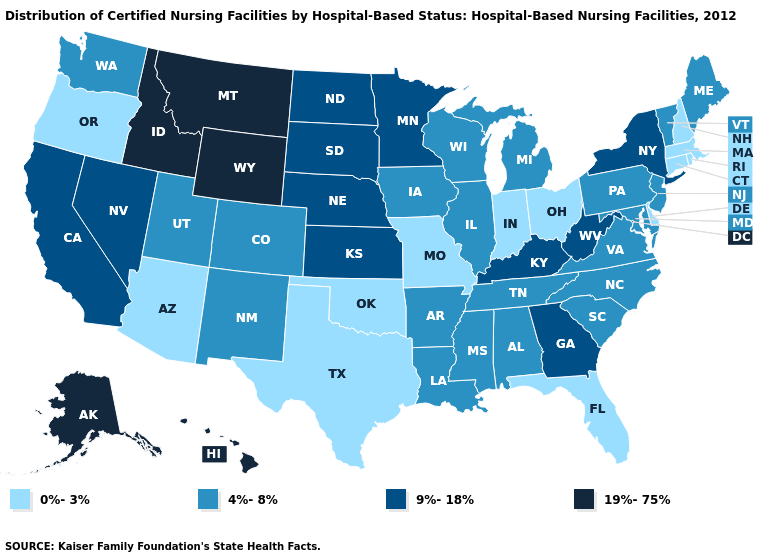Does Connecticut have the highest value in the Northeast?
Concise answer only. No. What is the value of Montana?
Quick response, please. 19%-75%. What is the highest value in the USA?
Short answer required. 19%-75%. Does the map have missing data?
Answer briefly. No. What is the lowest value in states that border Iowa?
Keep it brief. 0%-3%. Name the states that have a value in the range 4%-8%?
Concise answer only. Alabama, Arkansas, Colorado, Illinois, Iowa, Louisiana, Maine, Maryland, Michigan, Mississippi, New Jersey, New Mexico, North Carolina, Pennsylvania, South Carolina, Tennessee, Utah, Vermont, Virginia, Washington, Wisconsin. What is the value of Idaho?
Give a very brief answer. 19%-75%. What is the value of Delaware?
Concise answer only. 0%-3%. Does Nebraska have the lowest value in the USA?
Concise answer only. No. What is the value of Utah?
Quick response, please. 4%-8%. What is the lowest value in states that border Missouri?
Write a very short answer. 0%-3%. What is the value of New Mexico?
Give a very brief answer. 4%-8%. Does Arizona have the highest value in the USA?
Answer briefly. No. Among the states that border Wyoming , does Colorado have the highest value?
Quick response, please. No. Name the states that have a value in the range 0%-3%?
Give a very brief answer. Arizona, Connecticut, Delaware, Florida, Indiana, Massachusetts, Missouri, New Hampshire, Ohio, Oklahoma, Oregon, Rhode Island, Texas. 